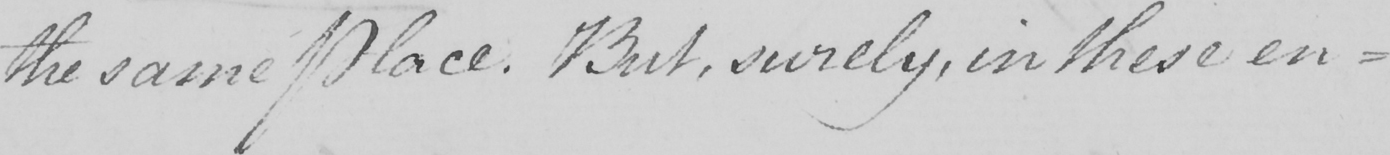Can you tell me what this handwritten text says? the same Place . But , surely , in these en- 